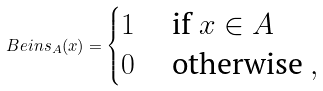Convert formula to latex. <formula><loc_0><loc_0><loc_500><loc_500>\ B e i n s _ { A } ( x ) = \begin{cases} 1 & \text { if } x \in A \\ 0 & \text { otherwise } , \end{cases}</formula> 